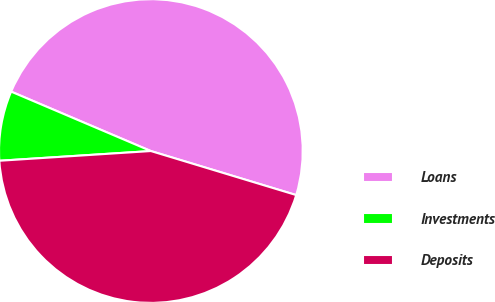Convert chart. <chart><loc_0><loc_0><loc_500><loc_500><pie_chart><fcel>Loans<fcel>Investments<fcel>Deposits<nl><fcel>48.28%<fcel>7.42%<fcel>44.3%<nl></chart> 